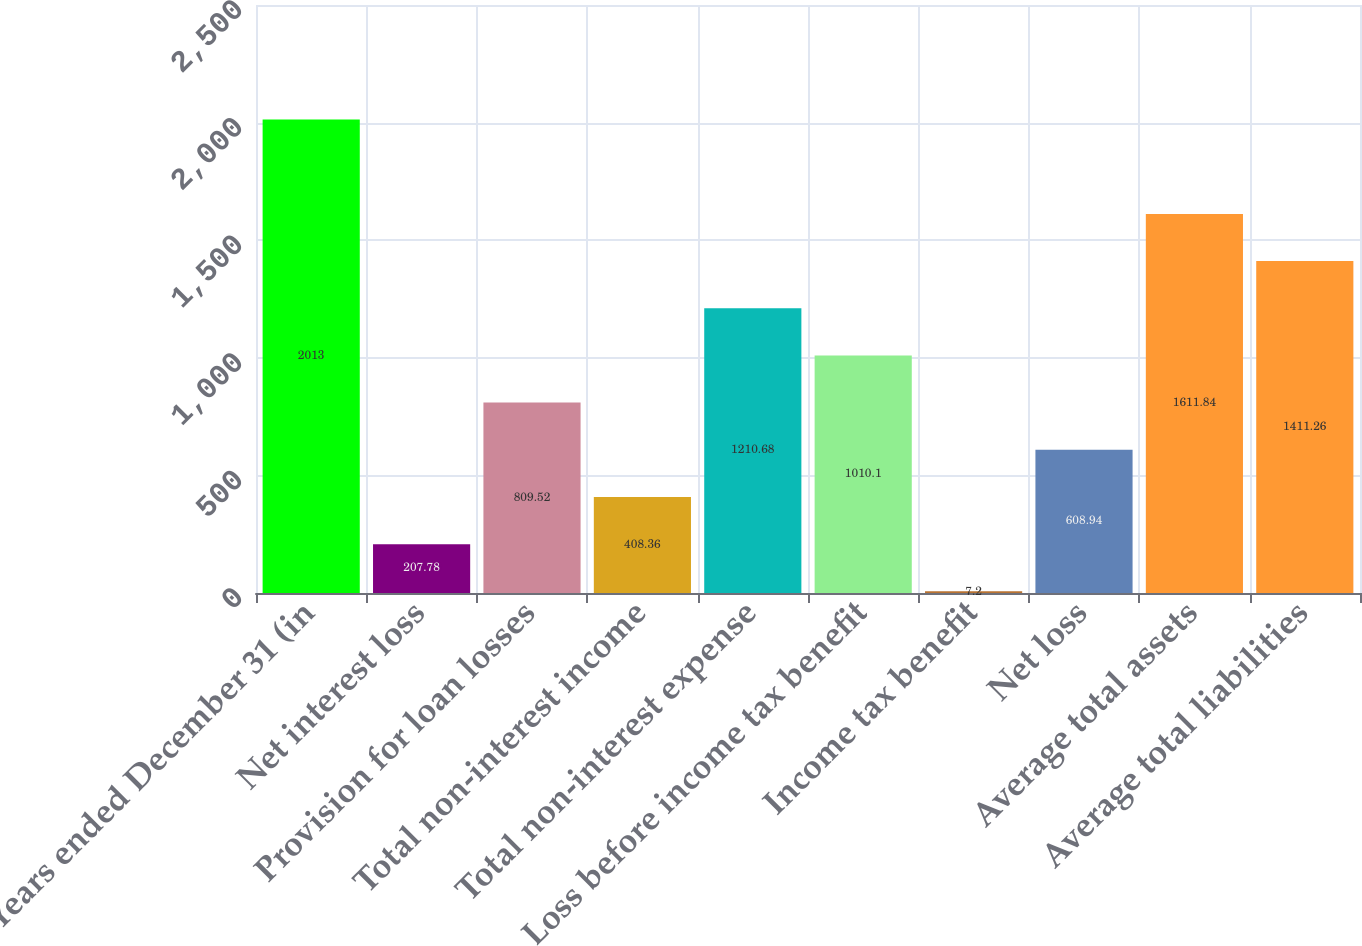Convert chart. <chart><loc_0><loc_0><loc_500><loc_500><bar_chart><fcel>Years ended December 31 (in<fcel>Net interest loss<fcel>Provision for loan losses<fcel>Total non-interest income<fcel>Total non-interest expense<fcel>Loss before income tax benefit<fcel>Income tax benefit<fcel>Net loss<fcel>Average total assets<fcel>Average total liabilities<nl><fcel>2013<fcel>207.78<fcel>809.52<fcel>408.36<fcel>1210.68<fcel>1010.1<fcel>7.2<fcel>608.94<fcel>1611.84<fcel>1411.26<nl></chart> 